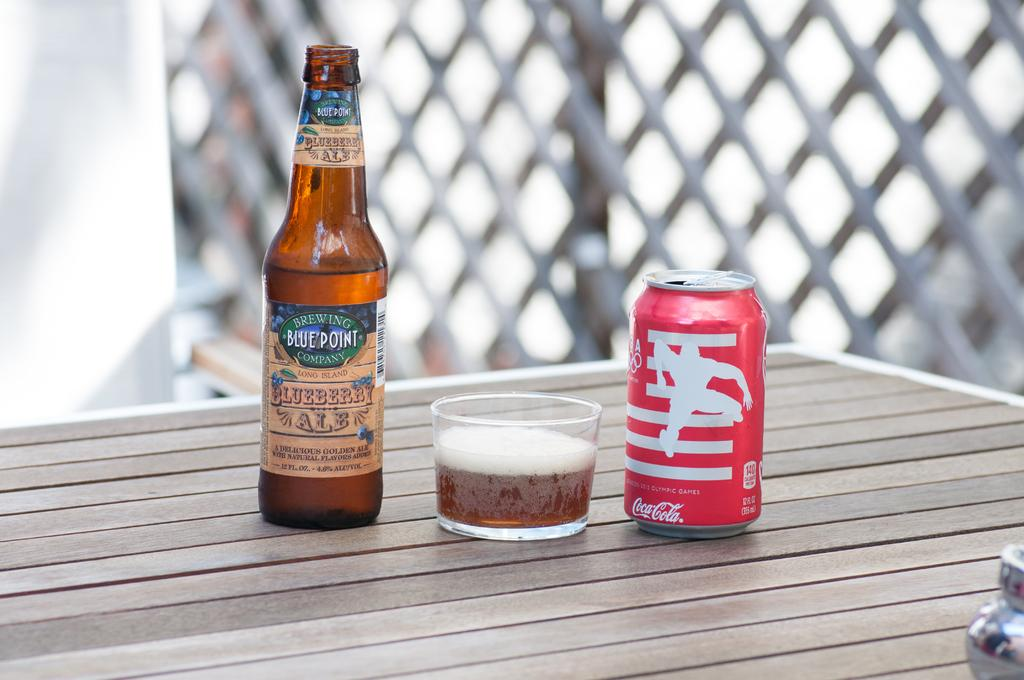Provide a one-sentence caption for the provided image. A can of Coca Cola stands to the right of a bottle of beer. 